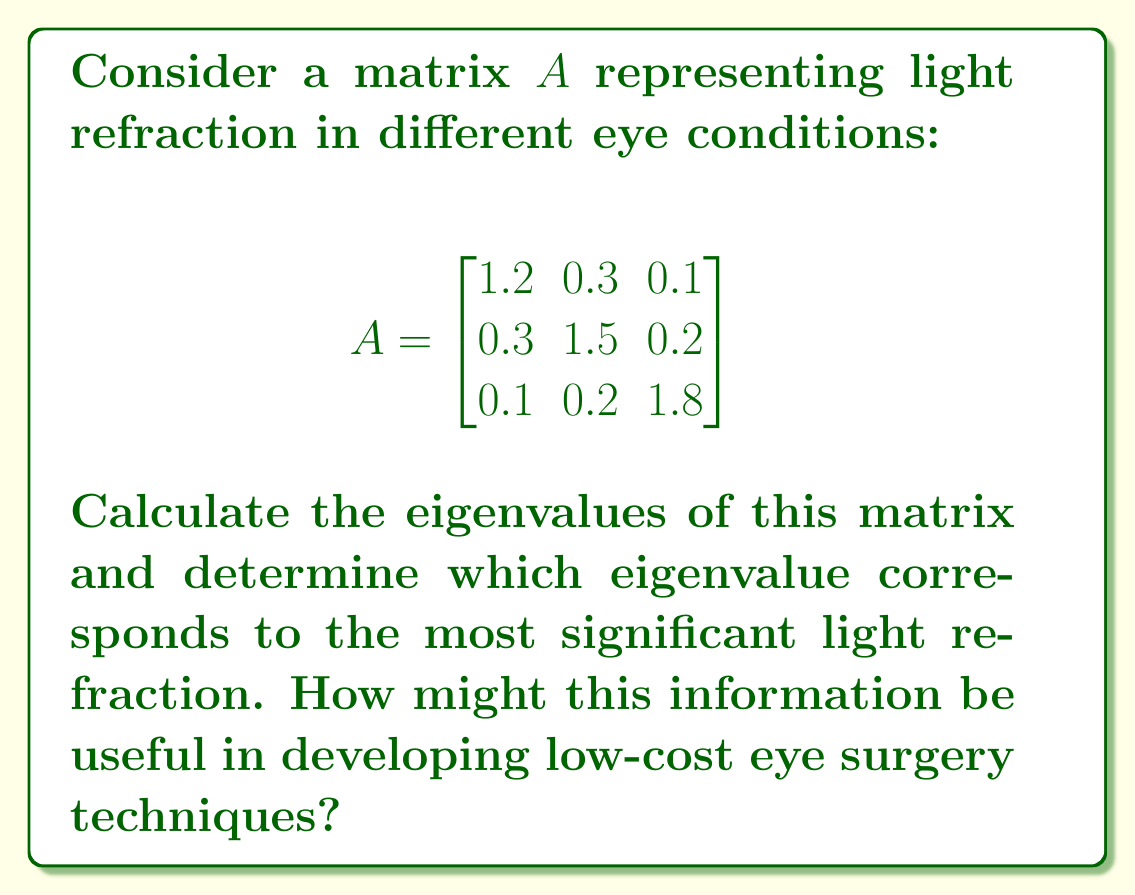Could you help me with this problem? To find the eigenvalues of matrix $A$, we need to solve the characteristic equation:

1) First, we calculate $det(A - \lambda I)$:

$$det(A - \lambda I) = \begin{vmatrix}
1.2 - \lambda & 0.3 & 0.1 \\
0.3 & 1.5 - \lambda & 0.2 \\
0.1 & 0.2 & 1.8 - \lambda
\end{vmatrix}$$

2) Expanding this determinant:

$$(1.2 - \lambda)[(1.5 - \lambda)(1.8 - \lambda) - 0.04] - 0.3[0.3(1.8 - \lambda) - 0.02] + 0.1[0.3(0.2) - 0.3(1.5 - \lambda)]$$

3) Simplifying:

$$\lambda^3 - 4.5\lambda^2 + 6.31\lambda - 2.808 = 0$$

4) This cubic equation can be solved using the cubic formula or numerical methods. The roots are the eigenvalues:

$\lambda_1 \approx 2.0018$
$\lambda_2 \approx 1.3991$
$\lambda_3 \approx 1.0991$

5) The largest eigenvalue ($\lambda_1 \approx 2.0018$) corresponds to the most significant light refraction.

This information can be useful in developing low-cost eye surgery techniques by:
- Identifying the most influential factors in light refraction
- Optimizing surgical procedures to target the most significant refractive issues
- Developing more accurate and cost-effective diagnostic tools
- Customizing treatments based on individual eye conditions
Answer: Eigenvalues: $\lambda_1 \approx 2.0018$, $\lambda_2 \approx 1.3991$, $\lambda_3 \approx 1.0991$. Largest eigenvalue ($\lambda_1$) indicates most significant refraction. 